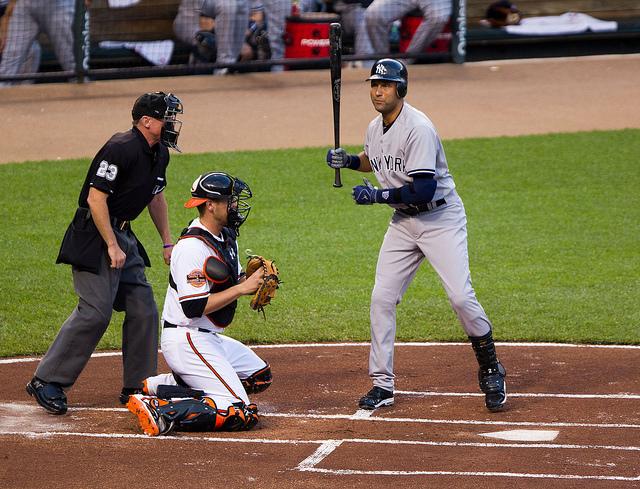What number is the ump?
Short answer required. 23. What sport are these men playing?
Keep it brief. Baseball. Which team is wearing white?
Keep it brief. Defense. The man is ready?
Quick response, please. No. Is the catcher behind the batter drunk?
Answer briefly. No. Did one of the players fall?
Answer briefly. No. What color is his helmet?
Answer briefly. Blue. Are the baseball players adults?
Be succinct. Yes. Is the batter ready to hit the ball?
Give a very brief answer. No. What position is wearing knee pads?
Be succinct. Catcher. Is he ready for the ball?
Quick response, please. No. 